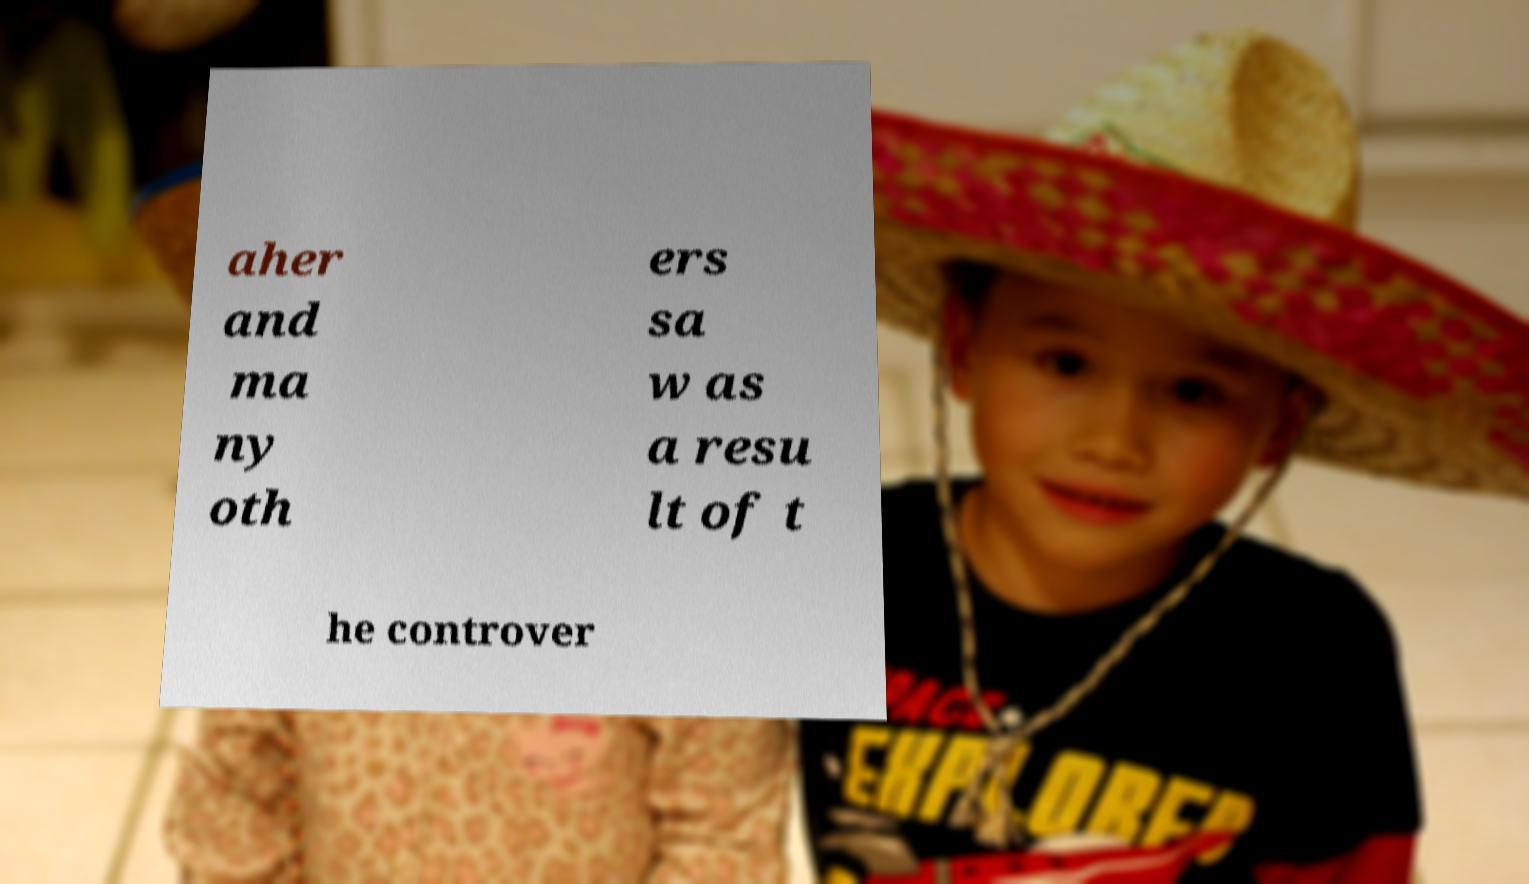I need the written content from this picture converted into text. Can you do that? aher and ma ny oth ers sa w as a resu lt of t he controver 